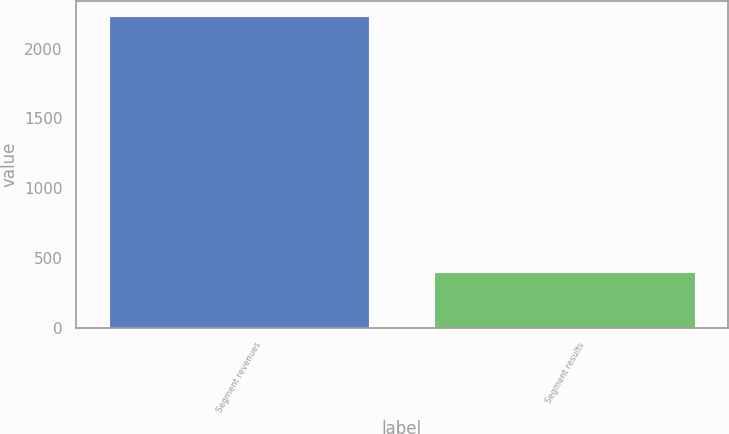Convert chart to OTSL. <chart><loc_0><loc_0><loc_500><loc_500><bar_chart><fcel>Segment revenues<fcel>Segment results<nl><fcel>2233<fcel>395<nl></chart> 